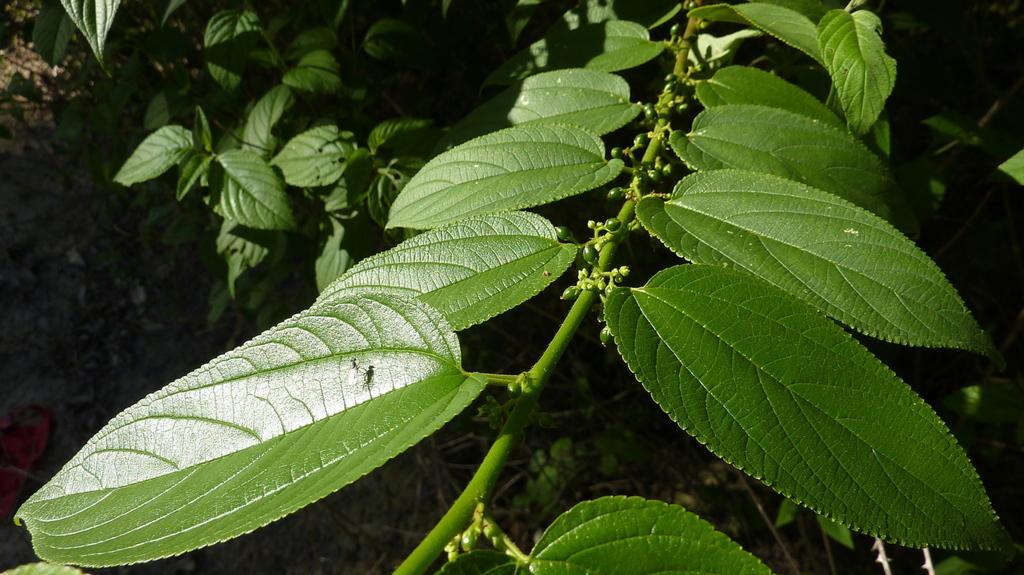In one or two sentences, can you explain what this image depicts? Here we can see green leaves and stem. 